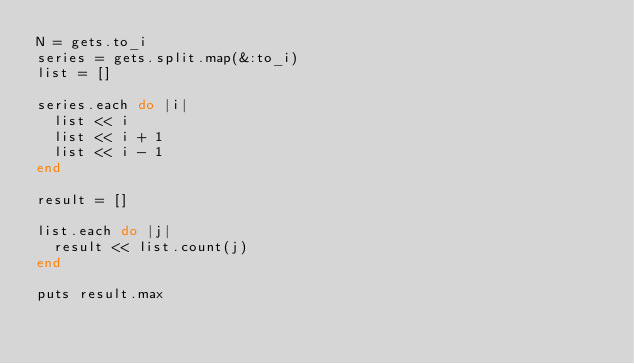<code> <loc_0><loc_0><loc_500><loc_500><_Ruby_>N = gets.to_i
series = gets.split.map(&:to_i)
list = []

series.each do |i|
  list << i
  list << i + 1
  list << i - 1 
end

result = []

list.each do |j|
  result << list.count(j)
end

puts result.max</code> 